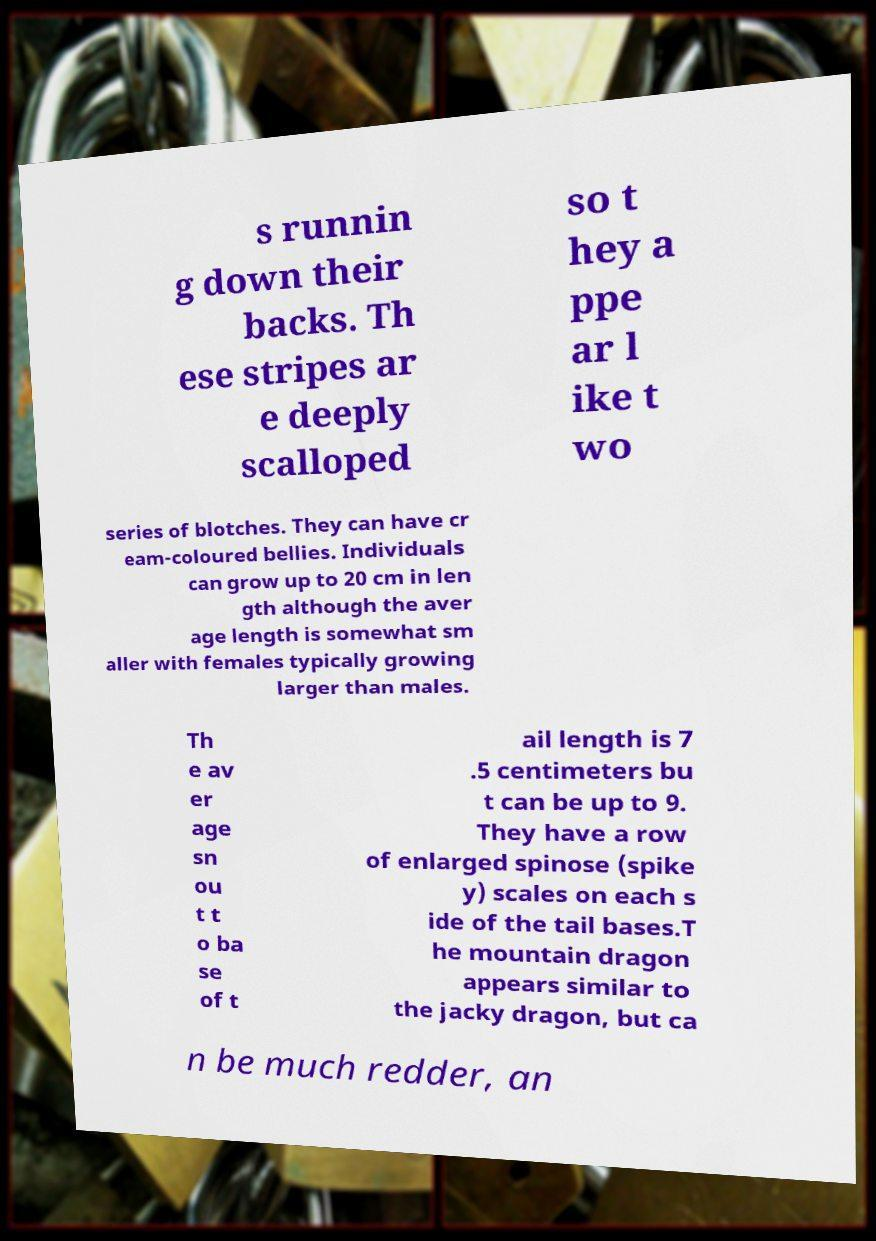I need the written content from this picture converted into text. Can you do that? s runnin g down their backs. Th ese stripes ar e deeply scalloped so t hey a ppe ar l ike t wo series of blotches. They can have cr eam-coloured bellies. Individuals can grow up to 20 cm in len gth although the aver age length is somewhat sm aller with females typically growing larger than males. Th e av er age sn ou t t o ba se of t ail length is 7 .5 centimeters bu t can be up to 9. They have a row of enlarged spinose (spike y) scales on each s ide of the tail bases.T he mountain dragon appears similar to the jacky dragon, but ca n be much redder, an 